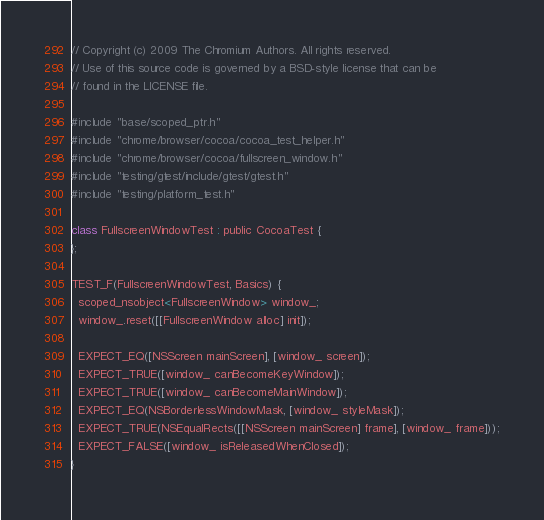Convert code to text. <code><loc_0><loc_0><loc_500><loc_500><_ObjectiveC_>// Copyright (c) 2009 The Chromium Authors. All rights reserved.
// Use of this source code is governed by a BSD-style license that can be
// found in the LICENSE file.

#include "base/scoped_ptr.h"
#include "chrome/browser/cocoa/cocoa_test_helper.h"
#include "chrome/browser/cocoa/fullscreen_window.h"
#include "testing/gtest/include/gtest/gtest.h"
#include "testing/platform_test.h"

class FullscreenWindowTest : public CocoaTest {
};

TEST_F(FullscreenWindowTest, Basics) {
  scoped_nsobject<FullscreenWindow> window_;
  window_.reset([[FullscreenWindow alloc] init]);

  EXPECT_EQ([NSScreen mainScreen], [window_ screen]);
  EXPECT_TRUE([window_ canBecomeKeyWindow]);
  EXPECT_TRUE([window_ canBecomeMainWindow]);
  EXPECT_EQ(NSBorderlessWindowMask, [window_ styleMask]);
  EXPECT_TRUE(NSEqualRects([[NSScreen mainScreen] frame], [window_ frame]));
  EXPECT_FALSE([window_ isReleasedWhenClosed]);
}


</code> 